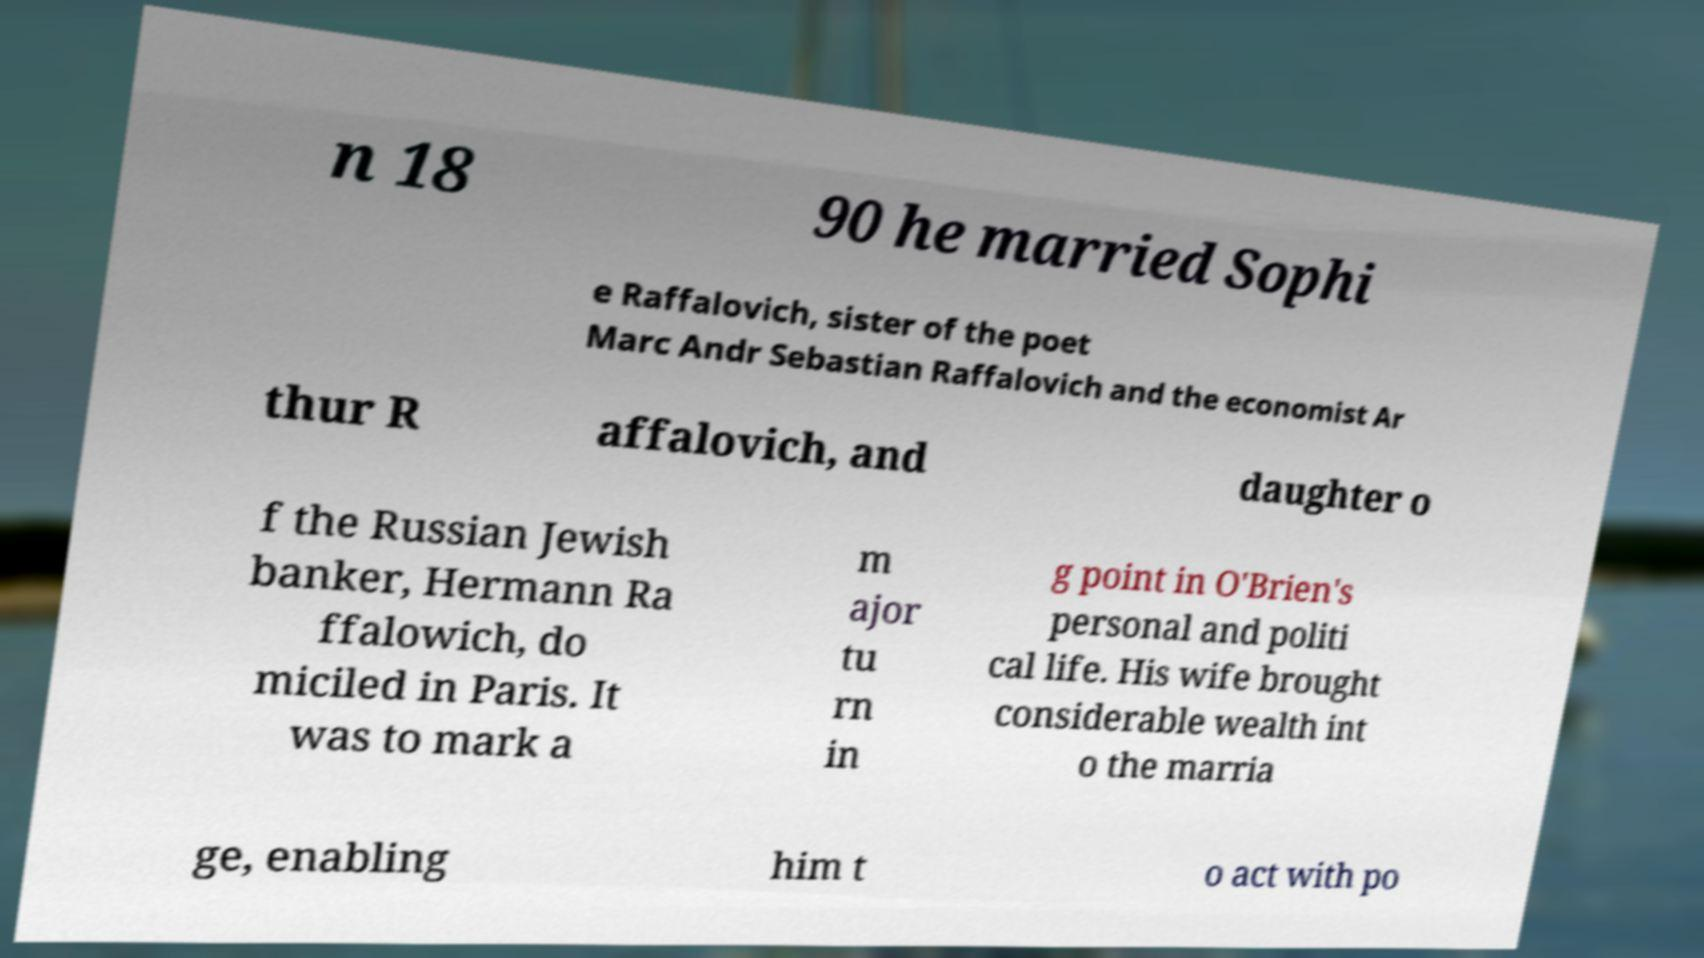There's text embedded in this image that I need extracted. Can you transcribe it verbatim? n 18 90 he married Sophi e Raffalovich, sister of the poet Marc Andr Sebastian Raffalovich and the economist Ar thur R affalovich, and daughter o f the Russian Jewish banker, Hermann Ra ffalowich, do miciled in Paris. It was to mark a m ajor tu rn in g point in O'Brien's personal and politi cal life. His wife brought considerable wealth int o the marria ge, enabling him t o act with po 